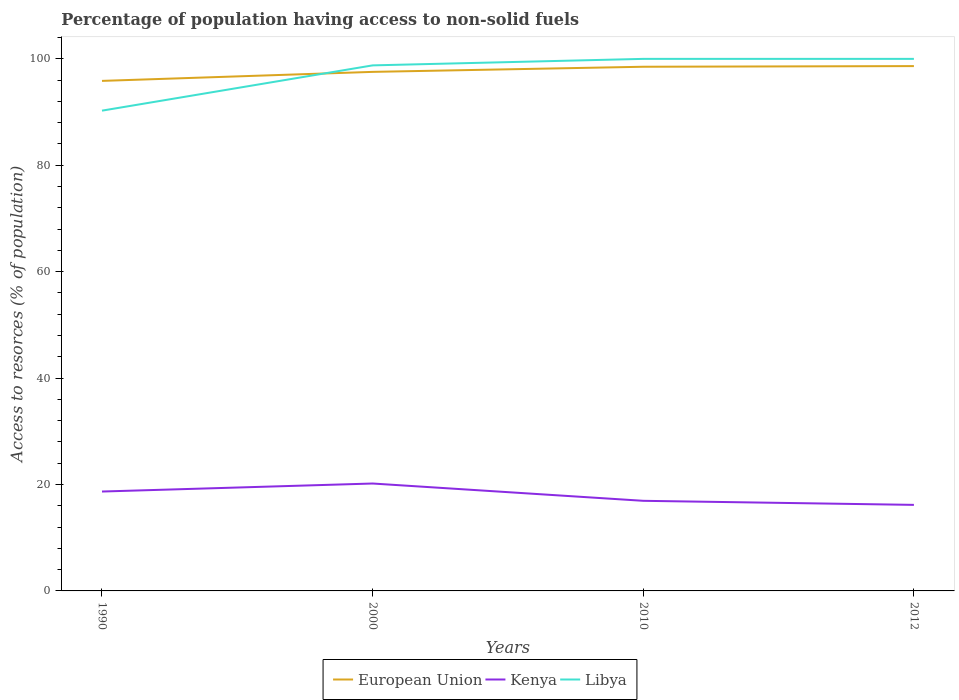Does the line corresponding to European Union intersect with the line corresponding to Kenya?
Your answer should be compact. No. Across all years, what is the maximum percentage of population having access to non-solid fuels in Kenya?
Offer a very short reply. 16.17. What is the total percentage of population having access to non-solid fuels in European Union in the graph?
Ensure brevity in your answer.  -0.96. What is the difference between the highest and the second highest percentage of population having access to non-solid fuels in European Union?
Offer a very short reply. 2.78. What is the difference between the highest and the lowest percentage of population having access to non-solid fuels in Libya?
Make the answer very short. 3. How many lines are there?
Keep it short and to the point. 3. Does the graph contain any zero values?
Provide a short and direct response. No. Does the graph contain grids?
Make the answer very short. No. Where does the legend appear in the graph?
Offer a terse response. Bottom center. How many legend labels are there?
Make the answer very short. 3. How are the legend labels stacked?
Make the answer very short. Horizontal. What is the title of the graph?
Keep it short and to the point. Percentage of population having access to non-solid fuels. What is the label or title of the Y-axis?
Offer a terse response. Access to resorces (% of population). What is the Access to resorces (% of population) of European Union in 1990?
Ensure brevity in your answer.  95.85. What is the Access to resorces (% of population) of Kenya in 1990?
Give a very brief answer. 18.68. What is the Access to resorces (% of population) in Libya in 1990?
Ensure brevity in your answer.  90.26. What is the Access to resorces (% of population) in European Union in 2000?
Offer a very short reply. 97.55. What is the Access to resorces (% of population) of Kenya in 2000?
Your response must be concise. 20.18. What is the Access to resorces (% of population) of Libya in 2000?
Your answer should be compact. 98.77. What is the Access to resorces (% of population) in European Union in 2010?
Ensure brevity in your answer.  98.51. What is the Access to resorces (% of population) in Kenya in 2010?
Provide a short and direct response. 16.93. What is the Access to resorces (% of population) in Libya in 2010?
Provide a short and direct response. 99.99. What is the Access to resorces (% of population) of European Union in 2012?
Your response must be concise. 98.63. What is the Access to resorces (% of population) in Kenya in 2012?
Give a very brief answer. 16.17. What is the Access to resorces (% of population) of Libya in 2012?
Offer a very short reply. 99.99. Across all years, what is the maximum Access to resorces (% of population) in European Union?
Provide a succinct answer. 98.63. Across all years, what is the maximum Access to resorces (% of population) in Kenya?
Give a very brief answer. 20.18. Across all years, what is the maximum Access to resorces (% of population) in Libya?
Your answer should be compact. 99.99. Across all years, what is the minimum Access to resorces (% of population) of European Union?
Ensure brevity in your answer.  95.85. Across all years, what is the minimum Access to resorces (% of population) in Kenya?
Make the answer very short. 16.17. Across all years, what is the minimum Access to resorces (% of population) in Libya?
Offer a very short reply. 90.26. What is the total Access to resorces (% of population) of European Union in the graph?
Offer a very short reply. 390.54. What is the total Access to resorces (% of population) of Kenya in the graph?
Your answer should be compact. 71.97. What is the total Access to resorces (% of population) of Libya in the graph?
Provide a succinct answer. 389.01. What is the difference between the Access to resorces (% of population) of European Union in 1990 and that in 2000?
Keep it short and to the point. -1.69. What is the difference between the Access to resorces (% of population) of Kenya in 1990 and that in 2000?
Make the answer very short. -1.51. What is the difference between the Access to resorces (% of population) in Libya in 1990 and that in 2000?
Your answer should be very brief. -8.51. What is the difference between the Access to resorces (% of population) in European Union in 1990 and that in 2010?
Keep it short and to the point. -2.66. What is the difference between the Access to resorces (% of population) of Kenya in 1990 and that in 2010?
Your response must be concise. 1.74. What is the difference between the Access to resorces (% of population) of Libya in 1990 and that in 2010?
Keep it short and to the point. -9.73. What is the difference between the Access to resorces (% of population) of European Union in 1990 and that in 2012?
Offer a terse response. -2.78. What is the difference between the Access to resorces (% of population) in Kenya in 1990 and that in 2012?
Your response must be concise. 2.51. What is the difference between the Access to resorces (% of population) of Libya in 1990 and that in 2012?
Provide a succinct answer. -9.73. What is the difference between the Access to resorces (% of population) in European Union in 2000 and that in 2010?
Make the answer very short. -0.96. What is the difference between the Access to resorces (% of population) of Kenya in 2000 and that in 2010?
Your response must be concise. 3.25. What is the difference between the Access to resorces (% of population) in Libya in 2000 and that in 2010?
Make the answer very short. -1.22. What is the difference between the Access to resorces (% of population) in European Union in 2000 and that in 2012?
Give a very brief answer. -1.09. What is the difference between the Access to resorces (% of population) in Kenya in 2000 and that in 2012?
Your response must be concise. 4.01. What is the difference between the Access to resorces (% of population) in Libya in 2000 and that in 2012?
Your response must be concise. -1.22. What is the difference between the Access to resorces (% of population) in European Union in 2010 and that in 2012?
Ensure brevity in your answer.  -0.12. What is the difference between the Access to resorces (% of population) of Kenya in 2010 and that in 2012?
Provide a short and direct response. 0.76. What is the difference between the Access to resorces (% of population) of European Union in 1990 and the Access to resorces (% of population) of Kenya in 2000?
Give a very brief answer. 75.67. What is the difference between the Access to resorces (% of population) of European Union in 1990 and the Access to resorces (% of population) of Libya in 2000?
Offer a terse response. -2.91. What is the difference between the Access to resorces (% of population) of Kenya in 1990 and the Access to resorces (% of population) of Libya in 2000?
Ensure brevity in your answer.  -80.09. What is the difference between the Access to resorces (% of population) in European Union in 1990 and the Access to resorces (% of population) in Kenya in 2010?
Provide a succinct answer. 78.92. What is the difference between the Access to resorces (% of population) of European Union in 1990 and the Access to resorces (% of population) of Libya in 2010?
Your answer should be compact. -4.14. What is the difference between the Access to resorces (% of population) of Kenya in 1990 and the Access to resorces (% of population) of Libya in 2010?
Offer a terse response. -81.31. What is the difference between the Access to resorces (% of population) of European Union in 1990 and the Access to resorces (% of population) of Kenya in 2012?
Your answer should be compact. 79.68. What is the difference between the Access to resorces (% of population) in European Union in 1990 and the Access to resorces (% of population) in Libya in 2012?
Ensure brevity in your answer.  -4.14. What is the difference between the Access to resorces (% of population) in Kenya in 1990 and the Access to resorces (% of population) in Libya in 2012?
Ensure brevity in your answer.  -81.31. What is the difference between the Access to resorces (% of population) of European Union in 2000 and the Access to resorces (% of population) of Kenya in 2010?
Give a very brief answer. 80.61. What is the difference between the Access to resorces (% of population) of European Union in 2000 and the Access to resorces (% of population) of Libya in 2010?
Provide a short and direct response. -2.44. What is the difference between the Access to resorces (% of population) in Kenya in 2000 and the Access to resorces (% of population) in Libya in 2010?
Provide a short and direct response. -79.81. What is the difference between the Access to resorces (% of population) of European Union in 2000 and the Access to resorces (% of population) of Kenya in 2012?
Give a very brief answer. 81.37. What is the difference between the Access to resorces (% of population) of European Union in 2000 and the Access to resorces (% of population) of Libya in 2012?
Keep it short and to the point. -2.44. What is the difference between the Access to resorces (% of population) in Kenya in 2000 and the Access to resorces (% of population) in Libya in 2012?
Offer a terse response. -79.81. What is the difference between the Access to resorces (% of population) in European Union in 2010 and the Access to resorces (% of population) in Kenya in 2012?
Ensure brevity in your answer.  82.34. What is the difference between the Access to resorces (% of population) of European Union in 2010 and the Access to resorces (% of population) of Libya in 2012?
Provide a succinct answer. -1.48. What is the difference between the Access to resorces (% of population) in Kenya in 2010 and the Access to resorces (% of population) in Libya in 2012?
Give a very brief answer. -83.06. What is the average Access to resorces (% of population) of European Union per year?
Keep it short and to the point. 97.64. What is the average Access to resorces (% of population) of Kenya per year?
Give a very brief answer. 17.99. What is the average Access to resorces (% of population) in Libya per year?
Make the answer very short. 97.25. In the year 1990, what is the difference between the Access to resorces (% of population) of European Union and Access to resorces (% of population) of Kenya?
Give a very brief answer. 77.17. In the year 1990, what is the difference between the Access to resorces (% of population) in European Union and Access to resorces (% of population) in Libya?
Provide a succinct answer. 5.59. In the year 1990, what is the difference between the Access to resorces (% of population) in Kenya and Access to resorces (% of population) in Libya?
Make the answer very short. -71.58. In the year 2000, what is the difference between the Access to resorces (% of population) of European Union and Access to resorces (% of population) of Kenya?
Give a very brief answer. 77.36. In the year 2000, what is the difference between the Access to resorces (% of population) of European Union and Access to resorces (% of population) of Libya?
Offer a very short reply. -1.22. In the year 2000, what is the difference between the Access to resorces (% of population) of Kenya and Access to resorces (% of population) of Libya?
Provide a succinct answer. -78.58. In the year 2010, what is the difference between the Access to resorces (% of population) in European Union and Access to resorces (% of population) in Kenya?
Ensure brevity in your answer.  81.58. In the year 2010, what is the difference between the Access to resorces (% of population) in European Union and Access to resorces (% of population) in Libya?
Ensure brevity in your answer.  -1.48. In the year 2010, what is the difference between the Access to resorces (% of population) of Kenya and Access to resorces (% of population) of Libya?
Your answer should be very brief. -83.06. In the year 2012, what is the difference between the Access to resorces (% of population) in European Union and Access to resorces (% of population) in Kenya?
Ensure brevity in your answer.  82.46. In the year 2012, what is the difference between the Access to resorces (% of population) in European Union and Access to resorces (% of population) in Libya?
Offer a very short reply. -1.36. In the year 2012, what is the difference between the Access to resorces (% of population) of Kenya and Access to resorces (% of population) of Libya?
Make the answer very short. -83.82. What is the ratio of the Access to resorces (% of population) of European Union in 1990 to that in 2000?
Offer a very short reply. 0.98. What is the ratio of the Access to resorces (% of population) in Kenya in 1990 to that in 2000?
Your answer should be compact. 0.93. What is the ratio of the Access to resorces (% of population) in Libya in 1990 to that in 2000?
Offer a terse response. 0.91. What is the ratio of the Access to resorces (% of population) of European Union in 1990 to that in 2010?
Make the answer very short. 0.97. What is the ratio of the Access to resorces (% of population) of Kenya in 1990 to that in 2010?
Keep it short and to the point. 1.1. What is the ratio of the Access to resorces (% of population) of Libya in 1990 to that in 2010?
Give a very brief answer. 0.9. What is the ratio of the Access to resorces (% of population) of European Union in 1990 to that in 2012?
Make the answer very short. 0.97. What is the ratio of the Access to resorces (% of population) in Kenya in 1990 to that in 2012?
Give a very brief answer. 1.16. What is the ratio of the Access to resorces (% of population) in Libya in 1990 to that in 2012?
Give a very brief answer. 0.9. What is the ratio of the Access to resorces (% of population) of European Union in 2000 to that in 2010?
Provide a short and direct response. 0.99. What is the ratio of the Access to resorces (% of population) of Kenya in 2000 to that in 2010?
Offer a very short reply. 1.19. What is the ratio of the Access to resorces (% of population) in Libya in 2000 to that in 2010?
Your answer should be compact. 0.99. What is the ratio of the Access to resorces (% of population) in European Union in 2000 to that in 2012?
Your answer should be very brief. 0.99. What is the ratio of the Access to resorces (% of population) in Kenya in 2000 to that in 2012?
Keep it short and to the point. 1.25. What is the ratio of the Access to resorces (% of population) of Libya in 2000 to that in 2012?
Ensure brevity in your answer.  0.99. What is the ratio of the Access to resorces (% of population) of European Union in 2010 to that in 2012?
Keep it short and to the point. 1. What is the ratio of the Access to resorces (% of population) in Kenya in 2010 to that in 2012?
Offer a terse response. 1.05. What is the ratio of the Access to resorces (% of population) in Libya in 2010 to that in 2012?
Your answer should be very brief. 1. What is the difference between the highest and the second highest Access to resorces (% of population) of European Union?
Your answer should be compact. 0.12. What is the difference between the highest and the second highest Access to resorces (% of population) in Kenya?
Ensure brevity in your answer.  1.51. What is the difference between the highest and the second highest Access to resorces (% of population) of Libya?
Keep it short and to the point. 0. What is the difference between the highest and the lowest Access to resorces (% of population) in European Union?
Provide a succinct answer. 2.78. What is the difference between the highest and the lowest Access to resorces (% of population) in Kenya?
Offer a very short reply. 4.01. What is the difference between the highest and the lowest Access to resorces (% of population) in Libya?
Provide a succinct answer. 9.73. 